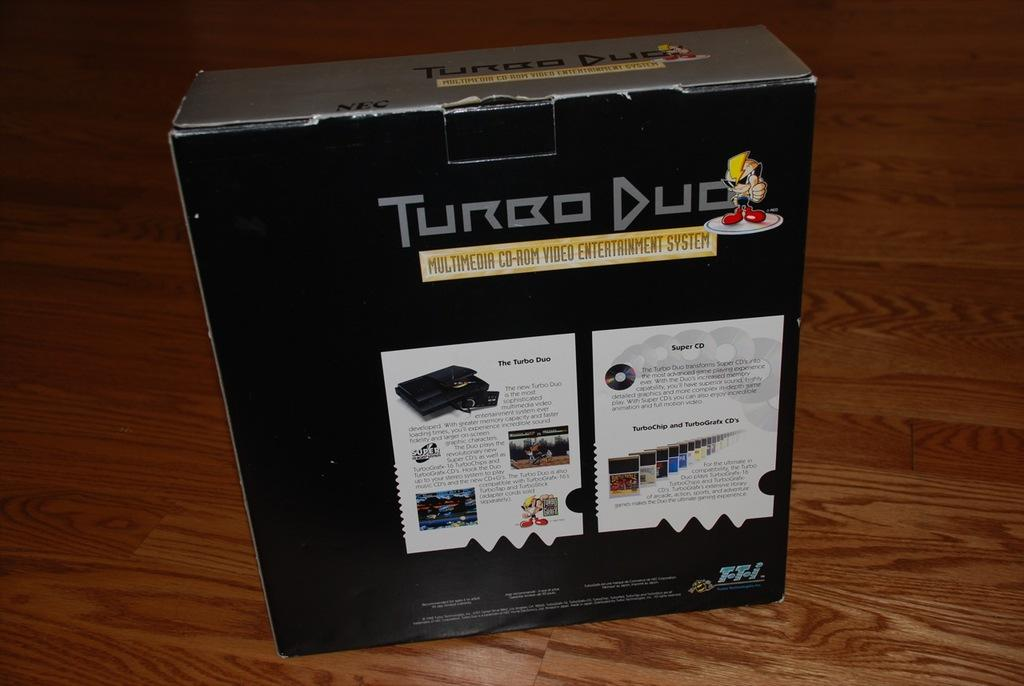What is the main object in the image? There is a black box in the image. What does the black box resemble? The black box resembles a video game box. What is visible at the bottom of the image? There is a floor visible at the bottom of the image. How many plates are stacked on top of the car in the image? There is no car or plates present in the image; it only features a black box that resembles a video game box and a floor visible at the bottom. 